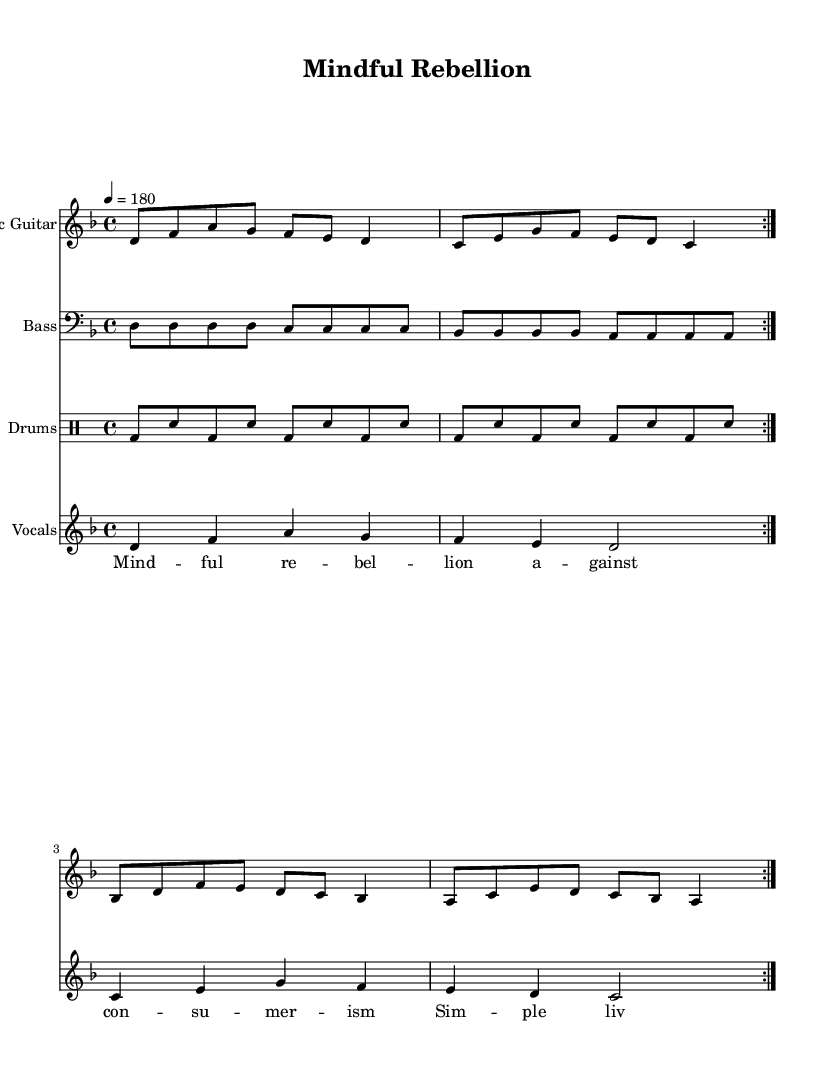What is the time signature of this music? The time signature appears at the beginning of the score and is indicated as 4/4, meaning there are four beats in each measure and the quarter note receives one beat.
Answer: 4/4 What is the tempo marking for this piece? The tempo is indicated at the beginning of the score with the marking showing that the piece should be played at a speed of 180 beats per minute.
Answer: 180 How many measures are present in the electric guitar part? The electric guitar part has a repeat indication that suggests two sections of four measures each, totaling eight measures.
Answer: Eight measures What key is this piece written in? The key signature is shown at the beginning of the music, indicating that the piece is in D minor, which is noted with one flat (B flat).
Answer: D minor What lyrical theme is represented in the song? The lyrics convey ideas of anti-consumerism and promoting simple living, which is reflected in the phrases used in the song.
Answer: Anti-consumerism and simple living How do the bass and drum parts contrast with the guitar part in this piece? The bass part provides a steady rhythmic foundation with repeated notes, while the drum part features a driving beat with bass drums and snare, complementing and contrasting with the more melodic and varying guitar part.
Answer: Rhythmically supportive What social message does the song communicate? The lyrics speak against materialism, expressing a desire for freedom from consumer culture, relevant themes in punk music reflecting a rejection of societal norms.
Answer: Rejection of materialism 